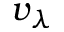<formula> <loc_0><loc_0><loc_500><loc_500>v _ { \lambda }</formula> 